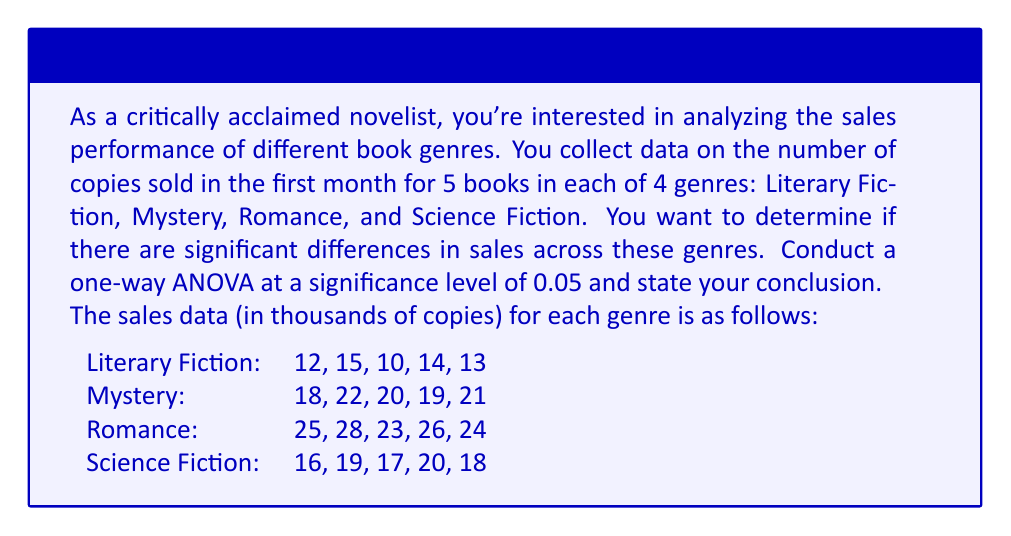Show me your answer to this math problem. To conduct a one-way ANOVA, we need to follow these steps:

1. Calculate the sum of squares between groups (SSB) and within groups (SSW).
2. Calculate the degrees of freedom between groups (dfB) and within groups (dfW).
3. Calculate the mean squares between groups (MSB) and within groups (MSW).
4. Calculate the F-statistic.
5. Compare the F-statistic to the critical F-value.

Step 1: Calculate SSB and SSW

First, we need to calculate the grand mean:

$$ \bar{X} = \frac{12+15+10+14+13+18+22+20+19+21+25+28+23+26+24+16+19+17+20+18}{20} = 19 $$

Now, we calculate SSB:

$$ SSB = 5[(12.8-19)^2 + (20-19)^2 + (25.2-19)^2 + (18-19)^2] = 504.8 $$

For SSW, we calculate the sum of squared deviations within each group:

Literary Fiction: $$(12-12.8)^2 + (15-12.8)^2 + (10-12.8)^2 + (14-12.8)^2 + (13-12.8)^2 = 16.8$$
Mystery: $$(18-20)^2 + (22-20)^2 + (20-20)^2 + (19-20)^2 + (21-20)^2 = 10$$
Romance: $$(25-25.2)^2 + (28-25.2)^2 + (23-25.2)^2 + (26-25.2)^2 + (24-25.2)^2 = 14.8$$
Science Fiction: $$(16-18)^2 + (19-18)^2 + (17-18)^2 + (20-18)^2 + (18-18)^2 = 10$$

$$ SSW = 16.8 + 10 + 14.8 + 10 = 51.6 $$

Step 2: Calculate degrees of freedom

$$ df_B = 4 - 1 = 3 $$
$$ df_W = 20 - 4 = 16 $$

Step 3: Calculate mean squares

$$ MSB = \frac{SSB}{df_B} = \frac{504.8}{3} = 168.27 $$
$$ MSW = \frac{SSW}{df_W} = \frac{51.6}{16} = 3.23 $$

Step 4: Calculate F-statistic

$$ F = \frac{MSB}{MSW} = \frac{168.27}{3.23} = 52.10 $$

Step 5: Compare to critical F-value

At α = 0.05, with df_B = 3 and df_W = 16, the critical F-value is approximately 3.24.

Since our calculated F-statistic (52.10) is greater than the critical F-value (3.24), we reject the null hypothesis.
Answer: Reject the null hypothesis. There is significant evidence at the 0.05 level to conclude that there are differences in book sales across the four genres (F(3,16) = 52.10, p < 0.05). 